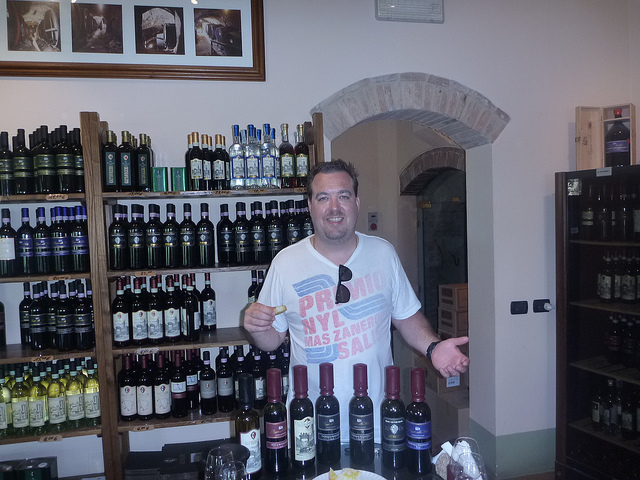How many bottles are in front of the man? The man is presenting a total of seven bottles positioned directly in front of him on the table, showcasing a variety of labels and presumably different types of contents. 